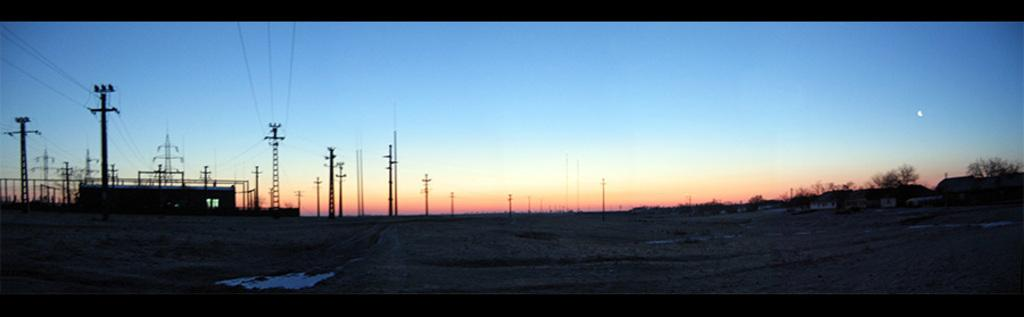Where was the image taken? The image was clicked outside. What type of vegetation can be seen on the right side of the image? There are trees on the right side of the image. What structures are present on the left side of the image? There are electric poles on the left side of the image. What is visible at the top of the image? The sky is visible at the top of the image. What type of canvas is used to create the painting in the image? There is no painting or canvas present in the image; it features an outdoor scene with trees, electric poles, and the sky. What is the cause of the trees growing on the right side of the image? The cause of the trees growing on the right side of the image is not mentioned in the provided facts, but it could be due to factors such as soil, sunlight, and climate. 